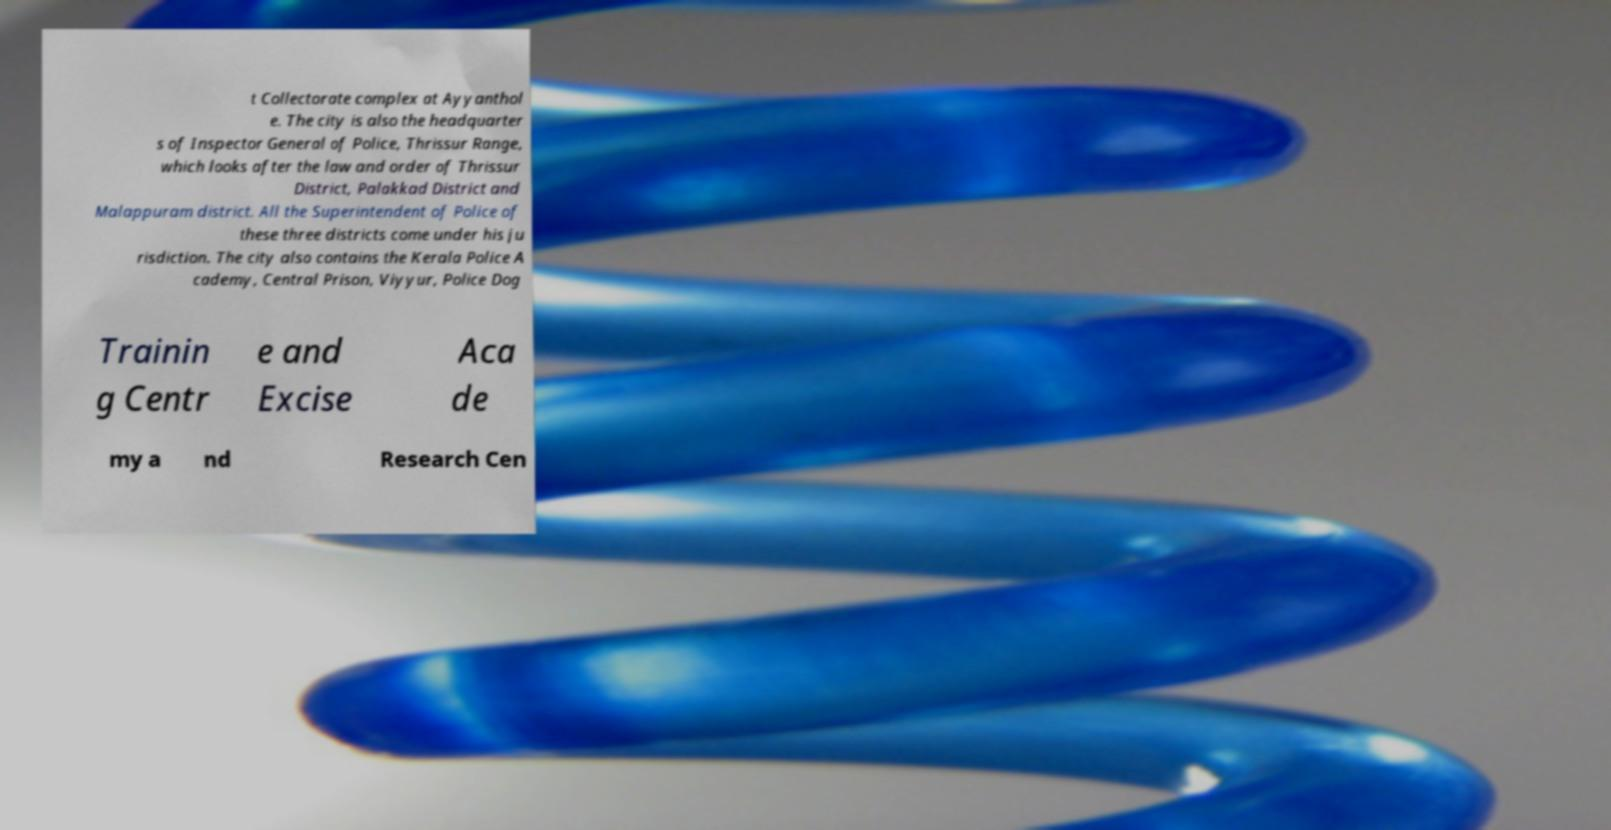Can you accurately transcribe the text from the provided image for me? t Collectorate complex at Ayyanthol e. The city is also the headquarter s of Inspector General of Police, Thrissur Range, which looks after the law and order of Thrissur District, Palakkad District and Malappuram district. All the Superintendent of Police of these three districts come under his ju risdiction. The city also contains the Kerala Police A cademy, Central Prison, Viyyur, Police Dog Trainin g Centr e and Excise Aca de my a nd Research Cen 